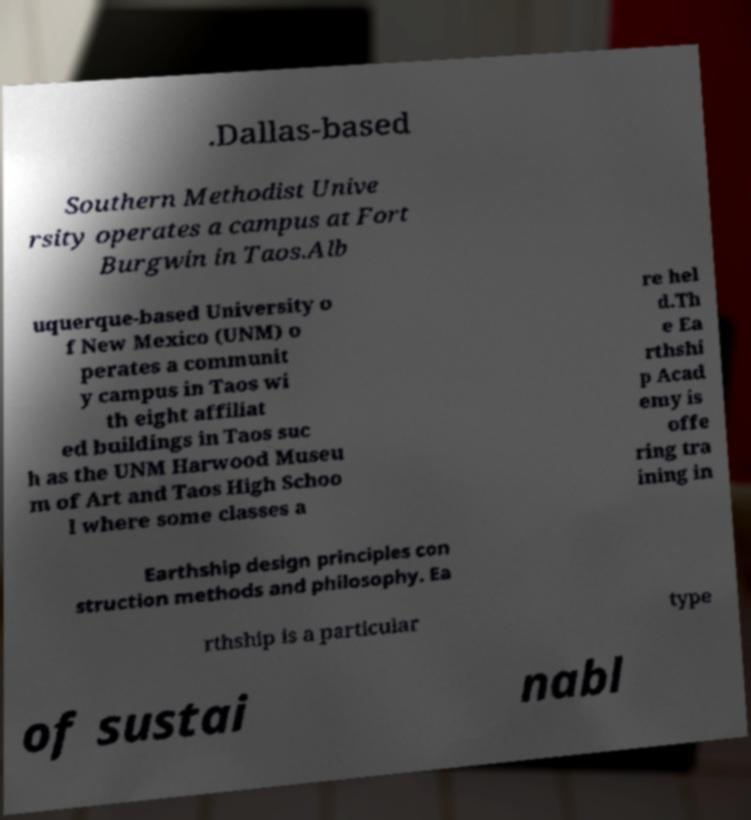Could you extract and type out the text from this image? .Dallas-based Southern Methodist Unive rsity operates a campus at Fort Burgwin in Taos.Alb uquerque-based University o f New Mexico (UNM) o perates a communit y campus in Taos wi th eight affiliat ed buildings in Taos suc h as the UNM Harwood Museu m of Art and Taos High Schoo l where some classes a re hel d.Th e Ea rthshi p Acad emy is offe ring tra ining in Earthship design principles con struction methods and philosophy. Ea rthship is a particular type of sustai nabl 